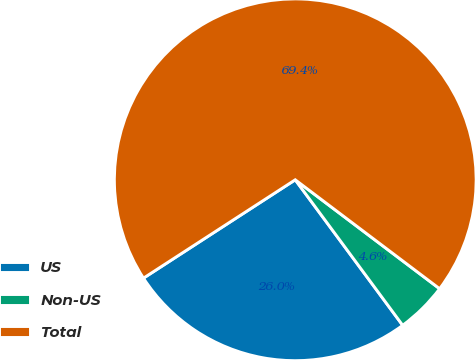Convert chart. <chart><loc_0><loc_0><loc_500><loc_500><pie_chart><fcel>US<fcel>Non-US<fcel>Total<nl><fcel>25.97%<fcel>4.59%<fcel>69.44%<nl></chart> 